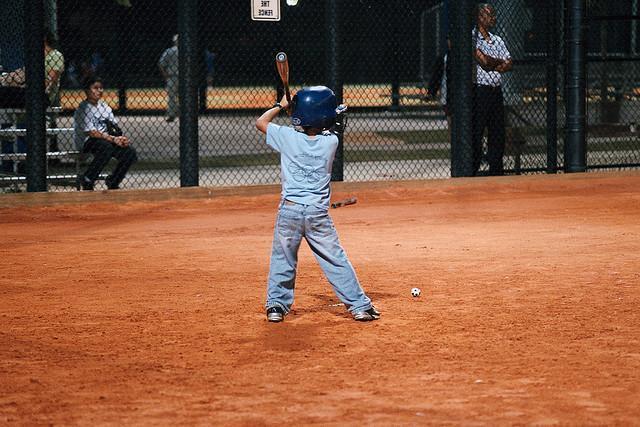How many people can be seen?
Give a very brief answer. 3. 